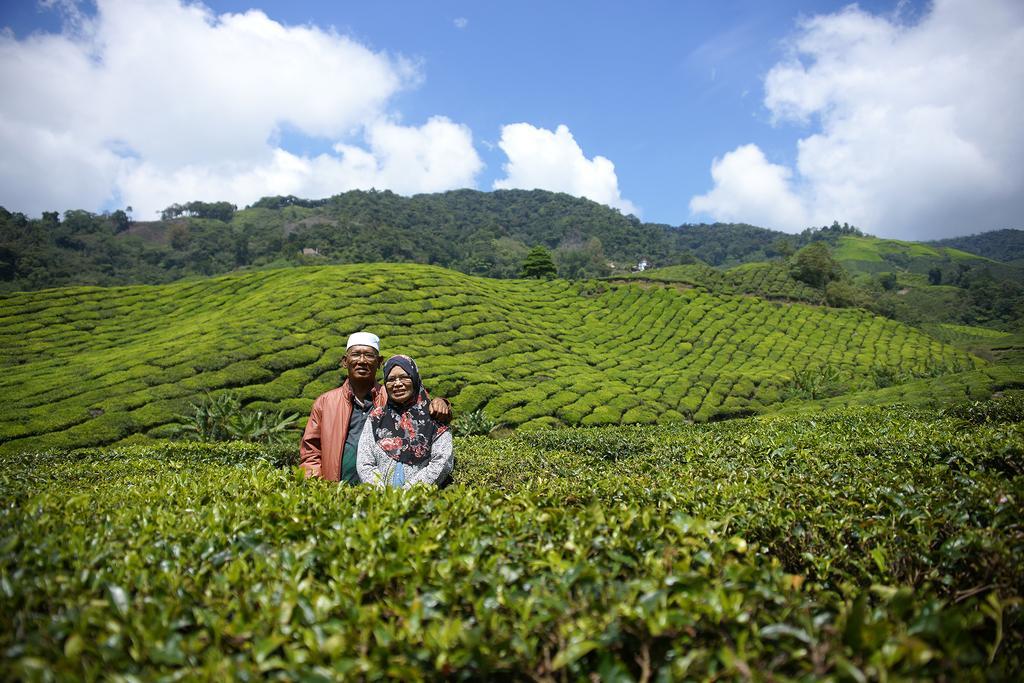Could you give a brief overview of what you see in this image? In this picture there is a couple standing in between few plants and there is a greenery ground behind them and there are trees in the background and the sky is a bit cloudy. 